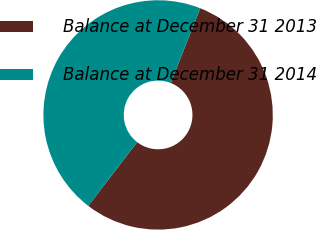<chart> <loc_0><loc_0><loc_500><loc_500><pie_chart><fcel>Balance at December 31 2013<fcel>Balance at December 31 2014<nl><fcel>54.44%<fcel>45.56%<nl></chart> 